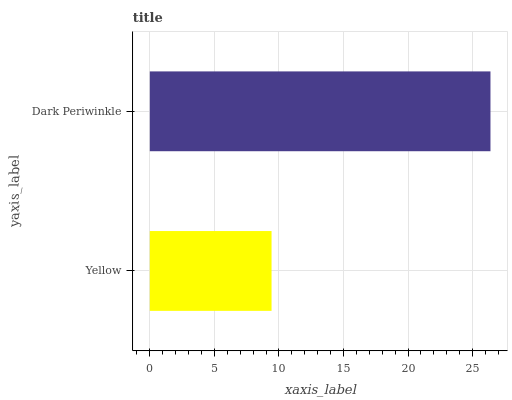Is Yellow the minimum?
Answer yes or no. Yes. Is Dark Periwinkle the maximum?
Answer yes or no. Yes. Is Dark Periwinkle the minimum?
Answer yes or no. No. Is Dark Periwinkle greater than Yellow?
Answer yes or no. Yes. Is Yellow less than Dark Periwinkle?
Answer yes or no. Yes. Is Yellow greater than Dark Periwinkle?
Answer yes or no. No. Is Dark Periwinkle less than Yellow?
Answer yes or no. No. Is Dark Periwinkle the high median?
Answer yes or no. Yes. Is Yellow the low median?
Answer yes or no. Yes. Is Yellow the high median?
Answer yes or no. No. Is Dark Periwinkle the low median?
Answer yes or no. No. 